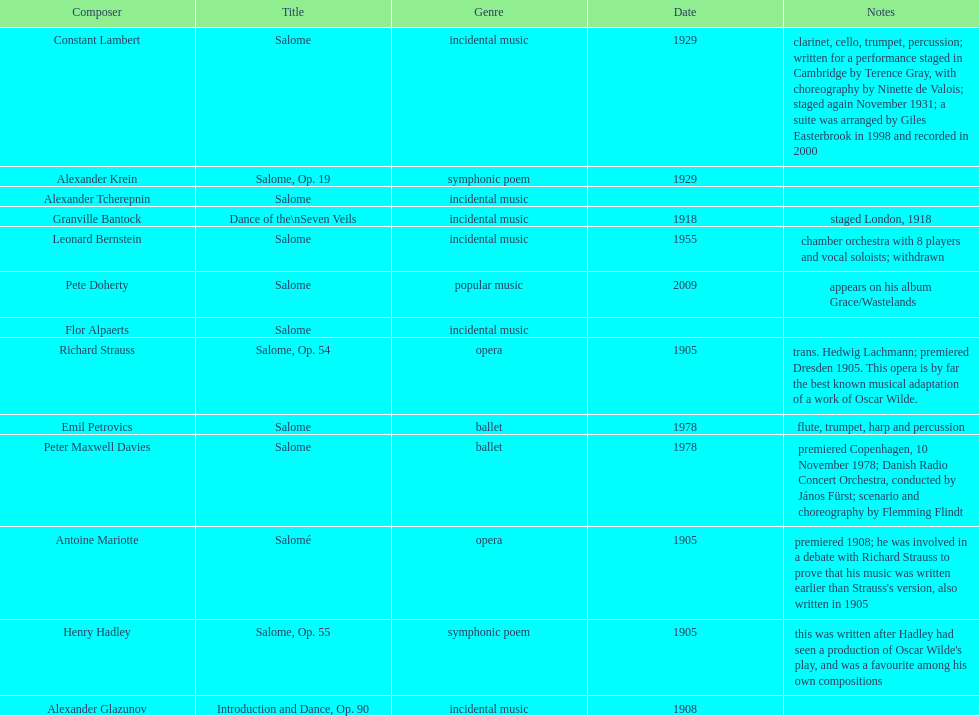How many pieces of work are titled "salome"? 11. 